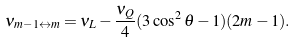<formula> <loc_0><loc_0><loc_500><loc_500>\nu _ { m - 1 \leftrightarrow m } = \nu _ { L } - \frac { \nu _ { Q } } { 4 } ( 3 \cos ^ { 2 } \theta - 1 ) ( 2 m - 1 ) .</formula> 